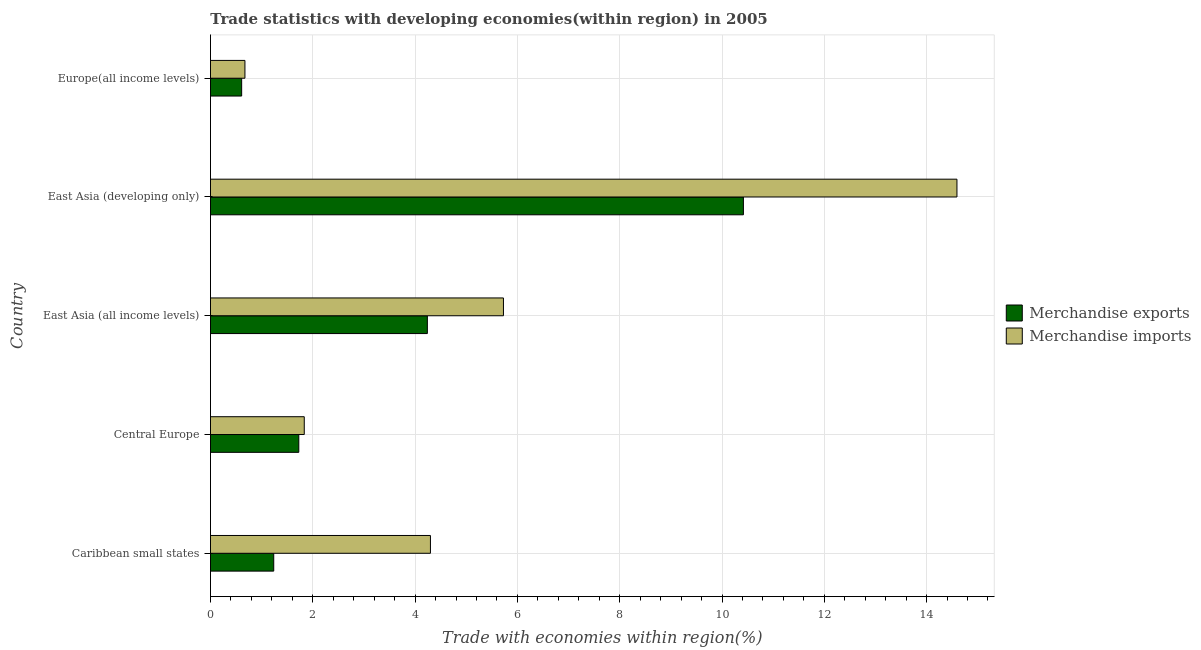How many different coloured bars are there?
Ensure brevity in your answer.  2. How many groups of bars are there?
Your answer should be compact. 5. Are the number of bars per tick equal to the number of legend labels?
Your answer should be compact. Yes. How many bars are there on the 4th tick from the top?
Offer a very short reply. 2. How many bars are there on the 1st tick from the bottom?
Your answer should be very brief. 2. What is the label of the 4th group of bars from the top?
Provide a short and direct response. Central Europe. What is the merchandise exports in Europe(all income levels)?
Your answer should be compact. 0.61. Across all countries, what is the maximum merchandise exports?
Ensure brevity in your answer.  10.42. Across all countries, what is the minimum merchandise imports?
Provide a short and direct response. 0.67. In which country was the merchandise imports maximum?
Your response must be concise. East Asia (developing only). In which country was the merchandise exports minimum?
Your response must be concise. Europe(all income levels). What is the total merchandise imports in the graph?
Your answer should be compact. 27.13. What is the difference between the merchandise imports in Central Europe and that in Europe(all income levels)?
Provide a short and direct response. 1.16. What is the difference between the merchandise exports in Central Europe and the merchandise imports in Caribbean small states?
Offer a very short reply. -2.57. What is the average merchandise exports per country?
Offer a very short reply. 3.65. What is the difference between the merchandise exports and merchandise imports in Europe(all income levels)?
Make the answer very short. -0.06. What is the ratio of the merchandise exports in Caribbean small states to that in East Asia (all income levels)?
Ensure brevity in your answer.  0.29. Is the merchandise exports in Caribbean small states less than that in Europe(all income levels)?
Your response must be concise. No. What is the difference between the highest and the second highest merchandise imports?
Offer a very short reply. 8.87. What is the difference between the highest and the lowest merchandise exports?
Keep it short and to the point. 9.81. In how many countries, is the merchandise exports greater than the average merchandise exports taken over all countries?
Your answer should be compact. 2. Is the sum of the merchandise exports in Central Europe and East Asia (developing only) greater than the maximum merchandise imports across all countries?
Give a very brief answer. No. What does the 1st bar from the bottom in East Asia (developing only) represents?
Your answer should be compact. Merchandise exports. How many bars are there?
Ensure brevity in your answer.  10. How many countries are there in the graph?
Your answer should be very brief. 5. Are the values on the major ticks of X-axis written in scientific E-notation?
Your answer should be compact. No. Does the graph contain grids?
Your answer should be compact. Yes. How are the legend labels stacked?
Make the answer very short. Vertical. What is the title of the graph?
Offer a very short reply. Trade statistics with developing economies(within region) in 2005. What is the label or title of the X-axis?
Your response must be concise. Trade with economies within region(%). What is the Trade with economies within region(%) in Merchandise exports in Caribbean small states?
Provide a short and direct response. 1.24. What is the Trade with economies within region(%) of Merchandise imports in Caribbean small states?
Ensure brevity in your answer.  4.3. What is the Trade with economies within region(%) in Merchandise exports in Central Europe?
Keep it short and to the point. 1.73. What is the Trade with economies within region(%) of Merchandise imports in Central Europe?
Your answer should be very brief. 1.83. What is the Trade with economies within region(%) of Merchandise exports in East Asia (all income levels)?
Your answer should be compact. 4.24. What is the Trade with economies within region(%) of Merchandise imports in East Asia (all income levels)?
Provide a succinct answer. 5.73. What is the Trade with economies within region(%) of Merchandise exports in East Asia (developing only)?
Give a very brief answer. 10.42. What is the Trade with economies within region(%) in Merchandise imports in East Asia (developing only)?
Your answer should be compact. 14.59. What is the Trade with economies within region(%) of Merchandise exports in Europe(all income levels)?
Offer a terse response. 0.61. What is the Trade with economies within region(%) in Merchandise imports in Europe(all income levels)?
Provide a short and direct response. 0.67. Across all countries, what is the maximum Trade with economies within region(%) of Merchandise exports?
Your response must be concise. 10.42. Across all countries, what is the maximum Trade with economies within region(%) of Merchandise imports?
Your answer should be compact. 14.59. Across all countries, what is the minimum Trade with economies within region(%) of Merchandise exports?
Your answer should be compact. 0.61. Across all countries, what is the minimum Trade with economies within region(%) of Merchandise imports?
Your answer should be very brief. 0.67. What is the total Trade with economies within region(%) of Merchandise exports in the graph?
Ensure brevity in your answer.  18.23. What is the total Trade with economies within region(%) of Merchandise imports in the graph?
Offer a very short reply. 27.13. What is the difference between the Trade with economies within region(%) of Merchandise exports in Caribbean small states and that in Central Europe?
Give a very brief answer. -0.49. What is the difference between the Trade with economies within region(%) of Merchandise imports in Caribbean small states and that in Central Europe?
Offer a very short reply. 2.47. What is the difference between the Trade with economies within region(%) of Merchandise exports in Caribbean small states and that in East Asia (all income levels)?
Give a very brief answer. -3. What is the difference between the Trade with economies within region(%) in Merchandise imports in Caribbean small states and that in East Asia (all income levels)?
Make the answer very short. -1.43. What is the difference between the Trade with economies within region(%) in Merchandise exports in Caribbean small states and that in East Asia (developing only)?
Offer a terse response. -9.18. What is the difference between the Trade with economies within region(%) in Merchandise imports in Caribbean small states and that in East Asia (developing only)?
Offer a terse response. -10.29. What is the difference between the Trade with economies within region(%) of Merchandise exports in Caribbean small states and that in Europe(all income levels)?
Make the answer very short. 0.63. What is the difference between the Trade with economies within region(%) in Merchandise imports in Caribbean small states and that in Europe(all income levels)?
Give a very brief answer. 3.63. What is the difference between the Trade with economies within region(%) of Merchandise exports in Central Europe and that in East Asia (all income levels)?
Offer a terse response. -2.51. What is the difference between the Trade with economies within region(%) of Merchandise imports in Central Europe and that in East Asia (all income levels)?
Your answer should be compact. -3.89. What is the difference between the Trade with economies within region(%) of Merchandise exports in Central Europe and that in East Asia (developing only)?
Your answer should be compact. -8.69. What is the difference between the Trade with economies within region(%) in Merchandise imports in Central Europe and that in East Asia (developing only)?
Your answer should be very brief. -12.76. What is the difference between the Trade with economies within region(%) of Merchandise exports in Central Europe and that in Europe(all income levels)?
Provide a short and direct response. 1.12. What is the difference between the Trade with economies within region(%) of Merchandise imports in Central Europe and that in Europe(all income levels)?
Offer a very short reply. 1.16. What is the difference between the Trade with economies within region(%) in Merchandise exports in East Asia (all income levels) and that in East Asia (developing only)?
Give a very brief answer. -6.18. What is the difference between the Trade with economies within region(%) in Merchandise imports in East Asia (all income levels) and that in East Asia (developing only)?
Keep it short and to the point. -8.87. What is the difference between the Trade with economies within region(%) of Merchandise exports in East Asia (all income levels) and that in Europe(all income levels)?
Keep it short and to the point. 3.63. What is the difference between the Trade with economies within region(%) in Merchandise imports in East Asia (all income levels) and that in Europe(all income levels)?
Ensure brevity in your answer.  5.05. What is the difference between the Trade with economies within region(%) of Merchandise exports in East Asia (developing only) and that in Europe(all income levels)?
Offer a very short reply. 9.81. What is the difference between the Trade with economies within region(%) of Merchandise imports in East Asia (developing only) and that in Europe(all income levels)?
Offer a terse response. 13.92. What is the difference between the Trade with economies within region(%) in Merchandise exports in Caribbean small states and the Trade with economies within region(%) in Merchandise imports in Central Europe?
Provide a short and direct response. -0.6. What is the difference between the Trade with economies within region(%) in Merchandise exports in Caribbean small states and the Trade with economies within region(%) in Merchandise imports in East Asia (all income levels)?
Give a very brief answer. -4.49. What is the difference between the Trade with economies within region(%) in Merchandise exports in Caribbean small states and the Trade with economies within region(%) in Merchandise imports in East Asia (developing only)?
Give a very brief answer. -13.36. What is the difference between the Trade with economies within region(%) in Merchandise exports in Caribbean small states and the Trade with economies within region(%) in Merchandise imports in Europe(all income levels)?
Offer a very short reply. 0.56. What is the difference between the Trade with economies within region(%) in Merchandise exports in Central Europe and the Trade with economies within region(%) in Merchandise imports in East Asia (all income levels)?
Keep it short and to the point. -4. What is the difference between the Trade with economies within region(%) in Merchandise exports in Central Europe and the Trade with economies within region(%) in Merchandise imports in East Asia (developing only)?
Offer a very short reply. -12.87. What is the difference between the Trade with economies within region(%) of Merchandise exports in Central Europe and the Trade with economies within region(%) of Merchandise imports in Europe(all income levels)?
Offer a terse response. 1.05. What is the difference between the Trade with economies within region(%) in Merchandise exports in East Asia (all income levels) and the Trade with economies within region(%) in Merchandise imports in East Asia (developing only)?
Give a very brief answer. -10.35. What is the difference between the Trade with economies within region(%) of Merchandise exports in East Asia (all income levels) and the Trade with economies within region(%) of Merchandise imports in Europe(all income levels)?
Give a very brief answer. 3.57. What is the difference between the Trade with economies within region(%) in Merchandise exports in East Asia (developing only) and the Trade with economies within region(%) in Merchandise imports in Europe(all income levels)?
Your response must be concise. 9.74. What is the average Trade with economies within region(%) in Merchandise exports per country?
Your answer should be very brief. 3.65. What is the average Trade with economies within region(%) of Merchandise imports per country?
Provide a succinct answer. 5.43. What is the difference between the Trade with economies within region(%) in Merchandise exports and Trade with economies within region(%) in Merchandise imports in Caribbean small states?
Your response must be concise. -3.06. What is the difference between the Trade with economies within region(%) in Merchandise exports and Trade with economies within region(%) in Merchandise imports in Central Europe?
Your answer should be very brief. -0.11. What is the difference between the Trade with economies within region(%) of Merchandise exports and Trade with economies within region(%) of Merchandise imports in East Asia (all income levels)?
Provide a succinct answer. -1.49. What is the difference between the Trade with economies within region(%) in Merchandise exports and Trade with economies within region(%) in Merchandise imports in East Asia (developing only)?
Provide a succinct answer. -4.17. What is the difference between the Trade with economies within region(%) of Merchandise exports and Trade with economies within region(%) of Merchandise imports in Europe(all income levels)?
Your response must be concise. -0.06. What is the ratio of the Trade with economies within region(%) in Merchandise exports in Caribbean small states to that in Central Europe?
Ensure brevity in your answer.  0.72. What is the ratio of the Trade with economies within region(%) of Merchandise imports in Caribbean small states to that in Central Europe?
Give a very brief answer. 2.35. What is the ratio of the Trade with economies within region(%) in Merchandise exports in Caribbean small states to that in East Asia (all income levels)?
Your response must be concise. 0.29. What is the ratio of the Trade with economies within region(%) in Merchandise imports in Caribbean small states to that in East Asia (all income levels)?
Keep it short and to the point. 0.75. What is the ratio of the Trade with economies within region(%) of Merchandise exports in Caribbean small states to that in East Asia (developing only)?
Provide a succinct answer. 0.12. What is the ratio of the Trade with economies within region(%) of Merchandise imports in Caribbean small states to that in East Asia (developing only)?
Offer a very short reply. 0.29. What is the ratio of the Trade with economies within region(%) in Merchandise exports in Caribbean small states to that in Europe(all income levels)?
Give a very brief answer. 2.03. What is the ratio of the Trade with economies within region(%) of Merchandise imports in Caribbean small states to that in Europe(all income levels)?
Your answer should be very brief. 6.38. What is the ratio of the Trade with economies within region(%) of Merchandise exports in Central Europe to that in East Asia (all income levels)?
Give a very brief answer. 0.41. What is the ratio of the Trade with economies within region(%) in Merchandise imports in Central Europe to that in East Asia (all income levels)?
Provide a short and direct response. 0.32. What is the ratio of the Trade with economies within region(%) in Merchandise exports in Central Europe to that in East Asia (developing only)?
Provide a succinct answer. 0.17. What is the ratio of the Trade with economies within region(%) of Merchandise imports in Central Europe to that in East Asia (developing only)?
Give a very brief answer. 0.13. What is the ratio of the Trade with economies within region(%) of Merchandise exports in Central Europe to that in Europe(all income levels)?
Make the answer very short. 2.83. What is the ratio of the Trade with economies within region(%) of Merchandise imports in Central Europe to that in Europe(all income levels)?
Offer a very short reply. 2.72. What is the ratio of the Trade with economies within region(%) in Merchandise exports in East Asia (all income levels) to that in East Asia (developing only)?
Provide a short and direct response. 0.41. What is the ratio of the Trade with economies within region(%) in Merchandise imports in East Asia (all income levels) to that in East Asia (developing only)?
Your answer should be compact. 0.39. What is the ratio of the Trade with economies within region(%) of Merchandise exports in East Asia (all income levels) to that in Europe(all income levels)?
Provide a short and direct response. 6.96. What is the ratio of the Trade with economies within region(%) of Merchandise imports in East Asia (all income levels) to that in Europe(all income levels)?
Provide a succinct answer. 8.5. What is the ratio of the Trade with economies within region(%) in Merchandise exports in East Asia (developing only) to that in Europe(all income levels)?
Provide a succinct answer. 17.09. What is the ratio of the Trade with economies within region(%) in Merchandise imports in East Asia (developing only) to that in Europe(all income levels)?
Keep it short and to the point. 21.66. What is the difference between the highest and the second highest Trade with economies within region(%) of Merchandise exports?
Your answer should be compact. 6.18. What is the difference between the highest and the second highest Trade with economies within region(%) in Merchandise imports?
Your answer should be very brief. 8.87. What is the difference between the highest and the lowest Trade with economies within region(%) in Merchandise exports?
Ensure brevity in your answer.  9.81. What is the difference between the highest and the lowest Trade with economies within region(%) in Merchandise imports?
Provide a succinct answer. 13.92. 